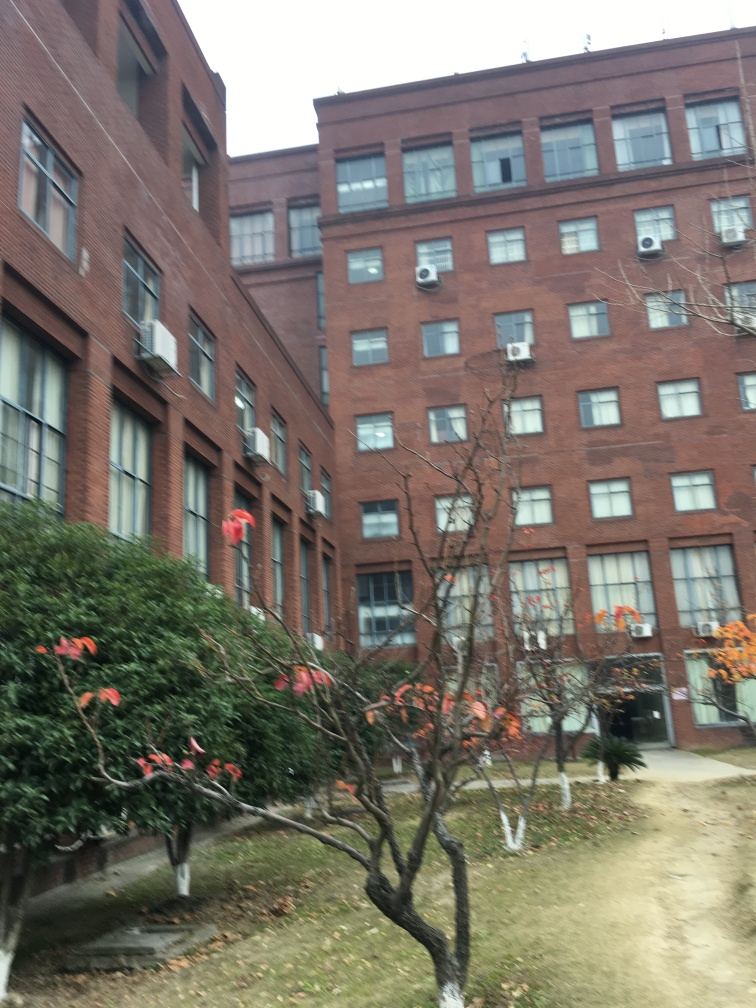Do the decorations on the building suggest a celebration or event? The red ribbons visible on the greenery indicate some form of festive decoration, perhaps related to a holiday season like Christmas. It implies a celebration or a festive spirit in the vicinity. 